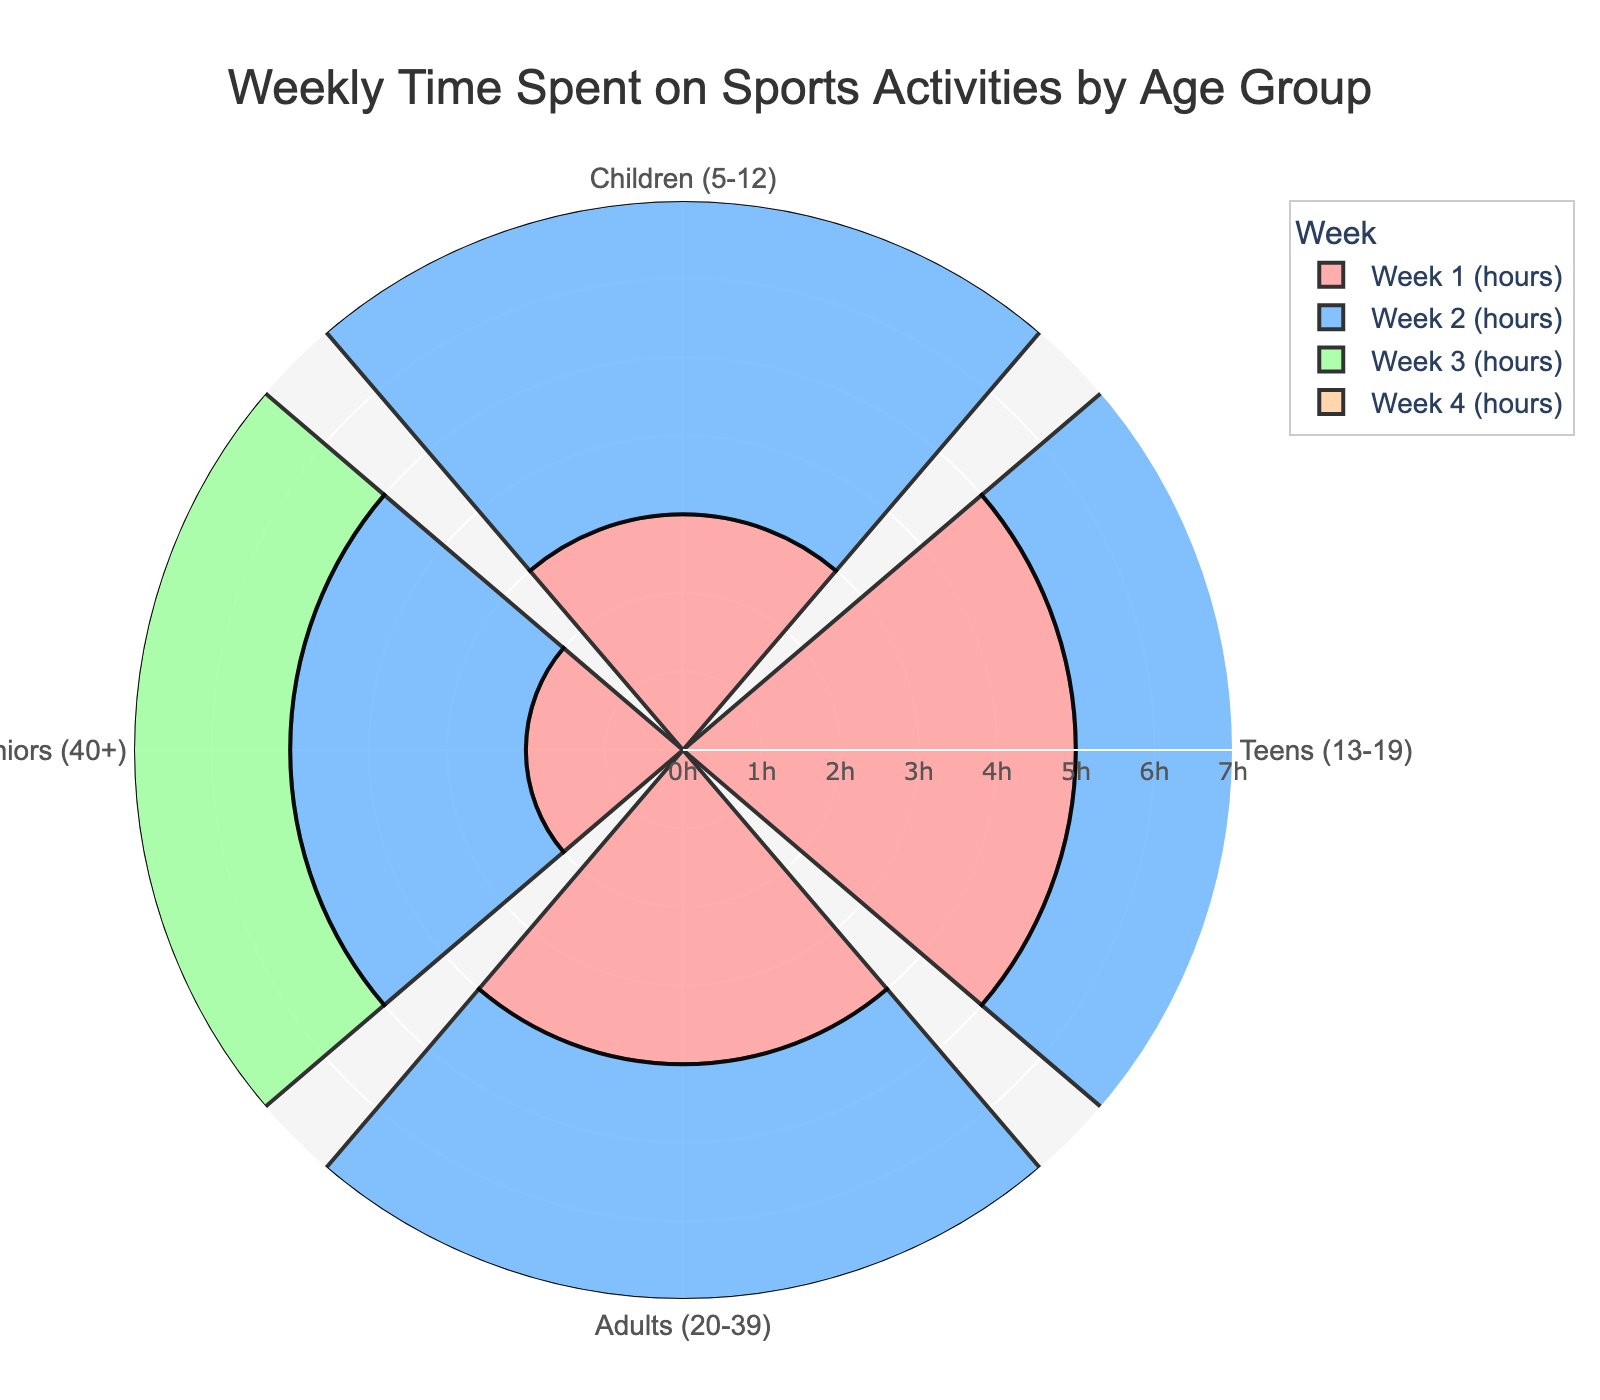What's the title of the figure? The title is usually displayed at the top of the figure. In this case, the title is "Weekly Time Spent on Sports Activities by Age Group."
Answer: Weekly Time Spent on Sports Activities by Age Group How many age groups are represented in the chart? The age groups are represented by different color segments and labeled around the chart. Count the unique labels to find the number of age groups. There are "Children (5-12)", "Teens (13-19)", "Adults (20-39)", and "Seniors (40+)."
Answer: 4 Which age group spent the least amount of time on sports in Week 1? In Week 1, compare the lengths of the segments for each age group. The shortest segment corresponds to "Seniors (40+)."
Answer: Seniors (40+) How much time did Teens (13-19) spend on sports in Week 2 compared to Adults (20-39) in the same week? Look at the lengths of the segments for Teens and Adults in Week 2. Teens spent 6 hours, and Adults spent 3 hours. This involves comparing the two values.
Answer: Teens spent 3 more hours than Adults What is the total time spent by Children on sports over the 4 weeks? Sum up the weekly hours for Children: 3 (Week 1) + 4 (Week 2) + 2 (Week 3) + 3 (Week 4) = 12 hours.
Answer: 12 hours Which week had the highest total time spent on sports across all age groups? Add the hours for each age group per week. Week 1: (3+5+4+2)=14, Week 2: (4+6+3+3)=16, Week 3: (2+4+5+2)=13, Week 4: (3+5+4+3)=15. Week 2 has the highest sum.
Answer: Week 2 How did sports time change from Week 1 to Week 4 for Adults (20-39)? Compare the hours for Adults in Week 1 and Week 4: Week 1 (4 hours) and Week 4 (4 hours). The time remained the same.
Answer: No change Among all age groups, which one showed the most variability in their weekly sports time? Look at the differences in weekly hours for each age group. Teens show a range from 4 to 6 hours, while other groups have smaller ranges.
Answer: Teens (13-19) What is the average weekly time spent on sports by Seniors (40+)? Calculate the average by summing the weekly hours for Seniors: (2+3+2+3)=10, then divide by 4 weeks. 10/4=2.5 hours.
Answer: 2.5 hours 